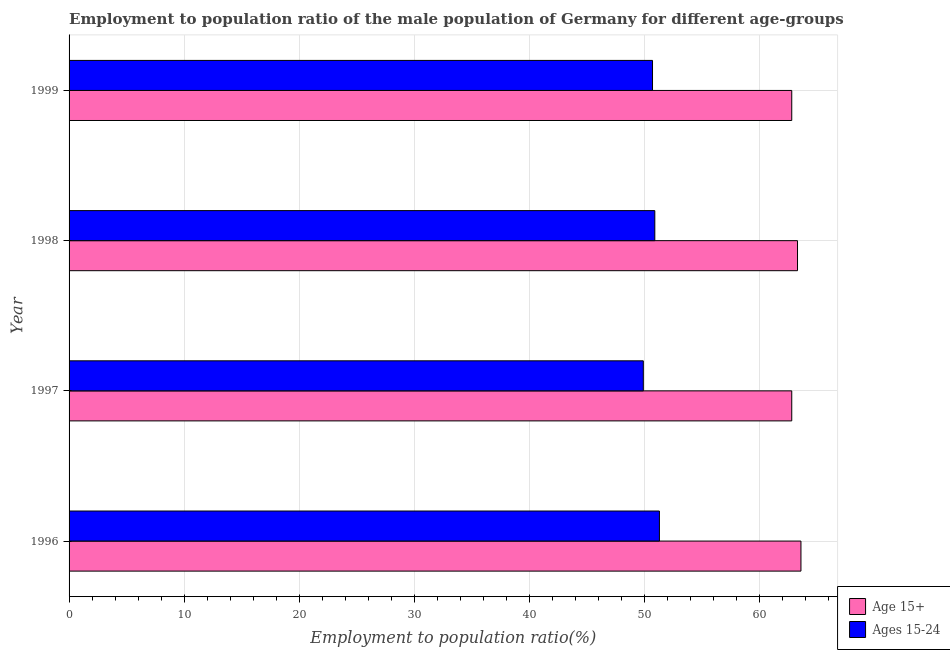How many groups of bars are there?
Provide a succinct answer. 4. Are the number of bars per tick equal to the number of legend labels?
Keep it short and to the point. Yes. Are the number of bars on each tick of the Y-axis equal?
Offer a terse response. Yes. How many bars are there on the 2nd tick from the top?
Your answer should be very brief. 2. What is the employment to population ratio(age 15-24) in 1997?
Your response must be concise. 49.9. Across all years, what is the maximum employment to population ratio(age 15+)?
Provide a succinct answer. 63.6. Across all years, what is the minimum employment to population ratio(age 15-24)?
Offer a terse response. 49.9. In which year was the employment to population ratio(age 15+) minimum?
Provide a short and direct response. 1997. What is the total employment to population ratio(age 15-24) in the graph?
Keep it short and to the point. 202.8. What is the difference between the employment to population ratio(age 15-24) in 1996 and the employment to population ratio(age 15+) in 1998?
Keep it short and to the point. -12. What is the average employment to population ratio(age 15+) per year?
Give a very brief answer. 63.12. What is the ratio of the employment to population ratio(age 15-24) in 1996 to that in 1997?
Provide a succinct answer. 1.03. What is the difference between the highest and the second highest employment to population ratio(age 15-24)?
Offer a terse response. 0.4. What is the difference between the highest and the lowest employment to population ratio(age 15+)?
Give a very brief answer. 0.8. What does the 2nd bar from the top in 1996 represents?
Offer a very short reply. Age 15+. What does the 2nd bar from the bottom in 1997 represents?
Provide a succinct answer. Ages 15-24. How many years are there in the graph?
Your response must be concise. 4. Are the values on the major ticks of X-axis written in scientific E-notation?
Give a very brief answer. No. Does the graph contain any zero values?
Offer a very short reply. No. Does the graph contain grids?
Offer a very short reply. Yes. How many legend labels are there?
Offer a very short reply. 2. What is the title of the graph?
Your answer should be very brief. Employment to population ratio of the male population of Germany for different age-groups. Does "State government" appear as one of the legend labels in the graph?
Provide a succinct answer. No. What is the label or title of the Y-axis?
Make the answer very short. Year. What is the Employment to population ratio(%) in Age 15+ in 1996?
Provide a short and direct response. 63.6. What is the Employment to population ratio(%) in Ages 15-24 in 1996?
Keep it short and to the point. 51.3. What is the Employment to population ratio(%) in Age 15+ in 1997?
Your answer should be very brief. 62.8. What is the Employment to population ratio(%) in Ages 15-24 in 1997?
Your response must be concise. 49.9. What is the Employment to population ratio(%) of Age 15+ in 1998?
Provide a succinct answer. 63.3. What is the Employment to population ratio(%) in Ages 15-24 in 1998?
Your answer should be compact. 50.9. What is the Employment to population ratio(%) in Age 15+ in 1999?
Keep it short and to the point. 62.8. What is the Employment to population ratio(%) in Ages 15-24 in 1999?
Keep it short and to the point. 50.7. Across all years, what is the maximum Employment to population ratio(%) in Age 15+?
Offer a very short reply. 63.6. Across all years, what is the maximum Employment to population ratio(%) in Ages 15-24?
Provide a short and direct response. 51.3. Across all years, what is the minimum Employment to population ratio(%) of Age 15+?
Give a very brief answer. 62.8. Across all years, what is the minimum Employment to population ratio(%) in Ages 15-24?
Give a very brief answer. 49.9. What is the total Employment to population ratio(%) in Age 15+ in the graph?
Your answer should be compact. 252.5. What is the total Employment to population ratio(%) of Ages 15-24 in the graph?
Offer a very short reply. 202.8. What is the difference between the Employment to population ratio(%) of Age 15+ in 1996 and that in 1997?
Offer a terse response. 0.8. What is the difference between the Employment to population ratio(%) in Age 15+ in 1996 and that in 1998?
Give a very brief answer. 0.3. What is the difference between the Employment to population ratio(%) in Age 15+ in 1996 and that in 1999?
Give a very brief answer. 0.8. What is the difference between the Employment to population ratio(%) in Ages 15-24 in 1996 and that in 1999?
Keep it short and to the point. 0.6. What is the difference between the Employment to population ratio(%) in Age 15+ in 1997 and that in 1998?
Offer a terse response. -0.5. What is the difference between the Employment to population ratio(%) in Ages 15-24 in 1998 and that in 1999?
Provide a short and direct response. 0.2. What is the difference between the Employment to population ratio(%) of Age 15+ in 1996 and the Employment to population ratio(%) of Ages 15-24 in 1997?
Your answer should be very brief. 13.7. What is the difference between the Employment to population ratio(%) of Age 15+ in 1996 and the Employment to population ratio(%) of Ages 15-24 in 1998?
Offer a terse response. 12.7. What is the difference between the Employment to population ratio(%) in Age 15+ in 1996 and the Employment to population ratio(%) in Ages 15-24 in 1999?
Ensure brevity in your answer.  12.9. What is the average Employment to population ratio(%) of Age 15+ per year?
Your response must be concise. 63.12. What is the average Employment to population ratio(%) of Ages 15-24 per year?
Keep it short and to the point. 50.7. In the year 1998, what is the difference between the Employment to population ratio(%) in Age 15+ and Employment to population ratio(%) in Ages 15-24?
Ensure brevity in your answer.  12.4. In the year 1999, what is the difference between the Employment to population ratio(%) of Age 15+ and Employment to population ratio(%) of Ages 15-24?
Make the answer very short. 12.1. What is the ratio of the Employment to population ratio(%) of Age 15+ in 1996 to that in 1997?
Provide a succinct answer. 1.01. What is the ratio of the Employment to population ratio(%) in Ages 15-24 in 1996 to that in 1997?
Keep it short and to the point. 1.03. What is the ratio of the Employment to population ratio(%) in Age 15+ in 1996 to that in 1998?
Give a very brief answer. 1. What is the ratio of the Employment to population ratio(%) in Ages 15-24 in 1996 to that in 1998?
Give a very brief answer. 1.01. What is the ratio of the Employment to population ratio(%) of Age 15+ in 1996 to that in 1999?
Make the answer very short. 1.01. What is the ratio of the Employment to population ratio(%) in Ages 15-24 in 1996 to that in 1999?
Make the answer very short. 1.01. What is the ratio of the Employment to population ratio(%) of Age 15+ in 1997 to that in 1998?
Your response must be concise. 0.99. What is the ratio of the Employment to population ratio(%) of Ages 15-24 in 1997 to that in 1998?
Offer a terse response. 0.98. What is the ratio of the Employment to population ratio(%) in Age 15+ in 1997 to that in 1999?
Make the answer very short. 1. What is the ratio of the Employment to population ratio(%) of Ages 15-24 in 1997 to that in 1999?
Your answer should be compact. 0.98. What is the ratio of the Employment to population ratio(%) in Age 15+ in 1998 to that in 1999?
Offer a terse response. 1.01. What is the difference between the highest and the second highest Employment to population ratio(%) of Age 15+?
Provide a succinct answer. 0.3. What is the difference between the highest and the lowest Employment to population ratio(%) in Ages 15-24?
Ensure brevity in your answer.  1.4. 